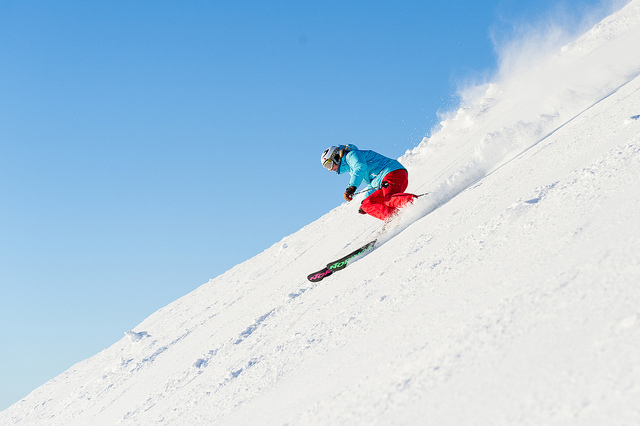<image>What is the viscosity of the snow? It is unknown what is the viscosity of the snow. What is the viscosity of the snow? I don't know the viscosity of the snow. It can be fast, wet, fluffy, or powdery. 